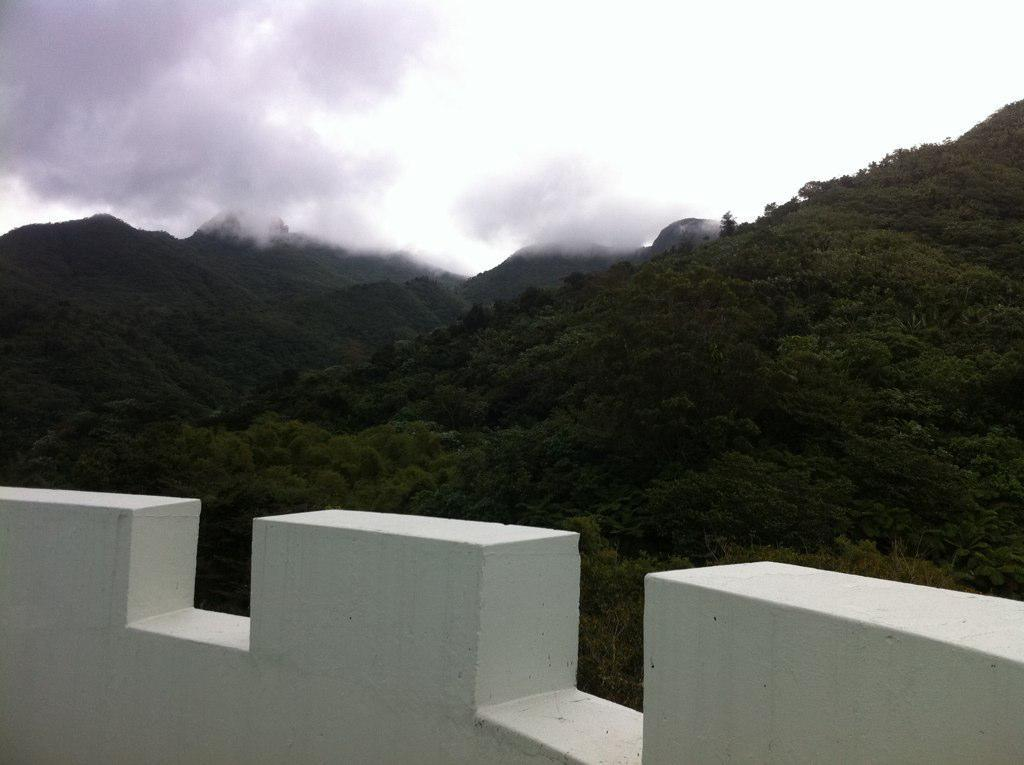What is located at the front of the image? There is a wall in the front of the image. What can be seen in the background of the image? There are trees in the background of the image. How would you describe the sky in the image? The sky is cloudy in the image. What type of metal can be seen hanging from the trees in the image? There is no metal visible in the image; it only features a wall, trees, and a cloudy sky. How many clocks are hanging from the branches of the trees in the image? There are no clocks present in the image; it only features a wall, trees, and a cloudy sky. 